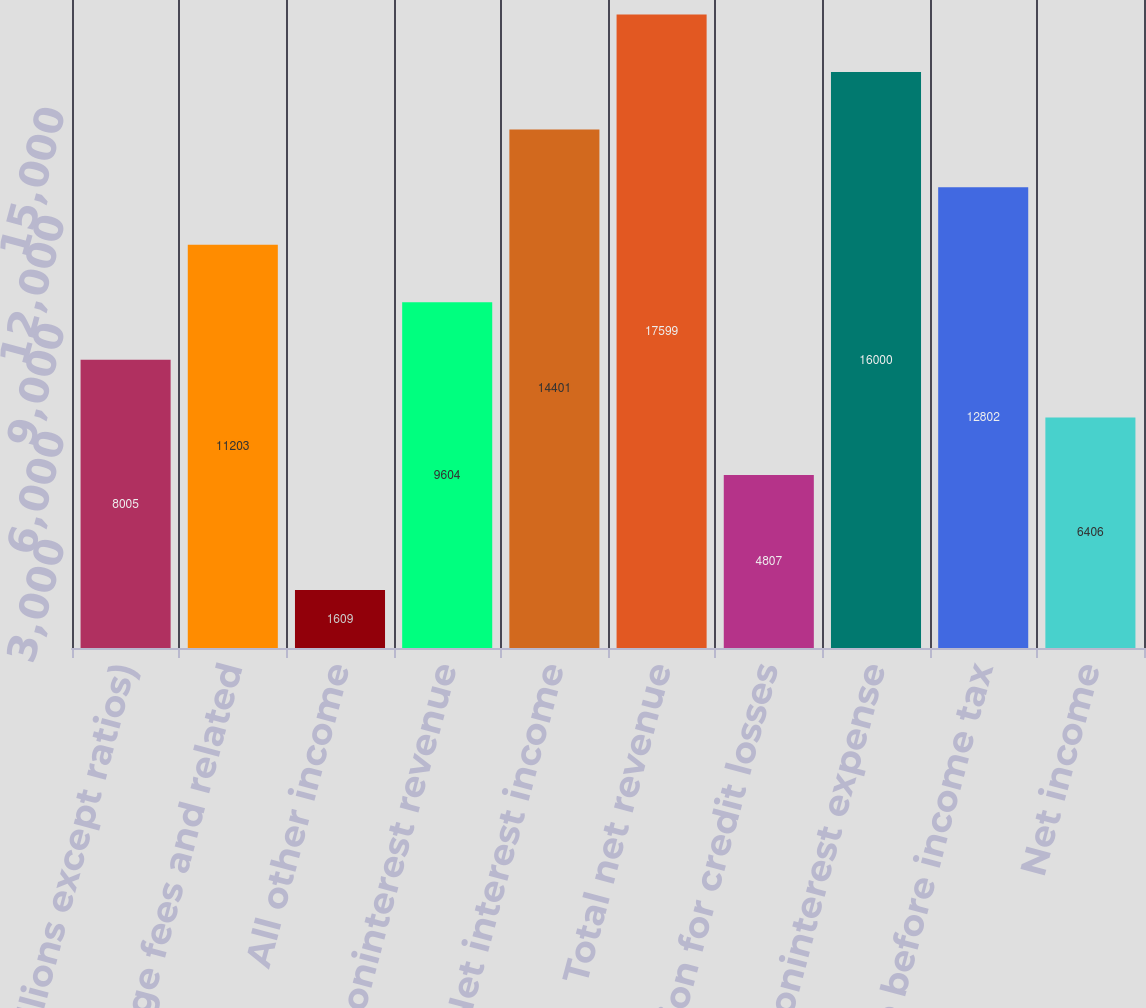Convert chart. <chart><loc_0><loc_0><loc_500><loc_500><bar_chart><fcel>(in millions except ratios)<fcel>Mortgage fees and related<fcel>All other income<fcel>Noninterest revenue<fcel>Net interest income<fcel>Total net revenue<fcel>Provision for credit losses<fcel>Noninterest expense<fcel>Income before income tax<fcel>Net income<nl><fcel>8005<fcel>11203<fcel>1609<fcel>9604<fcel>14401<fcel>17599<fcel>4807<fcel>16000<fcel>12802<fcel>6406<nl></chart> 